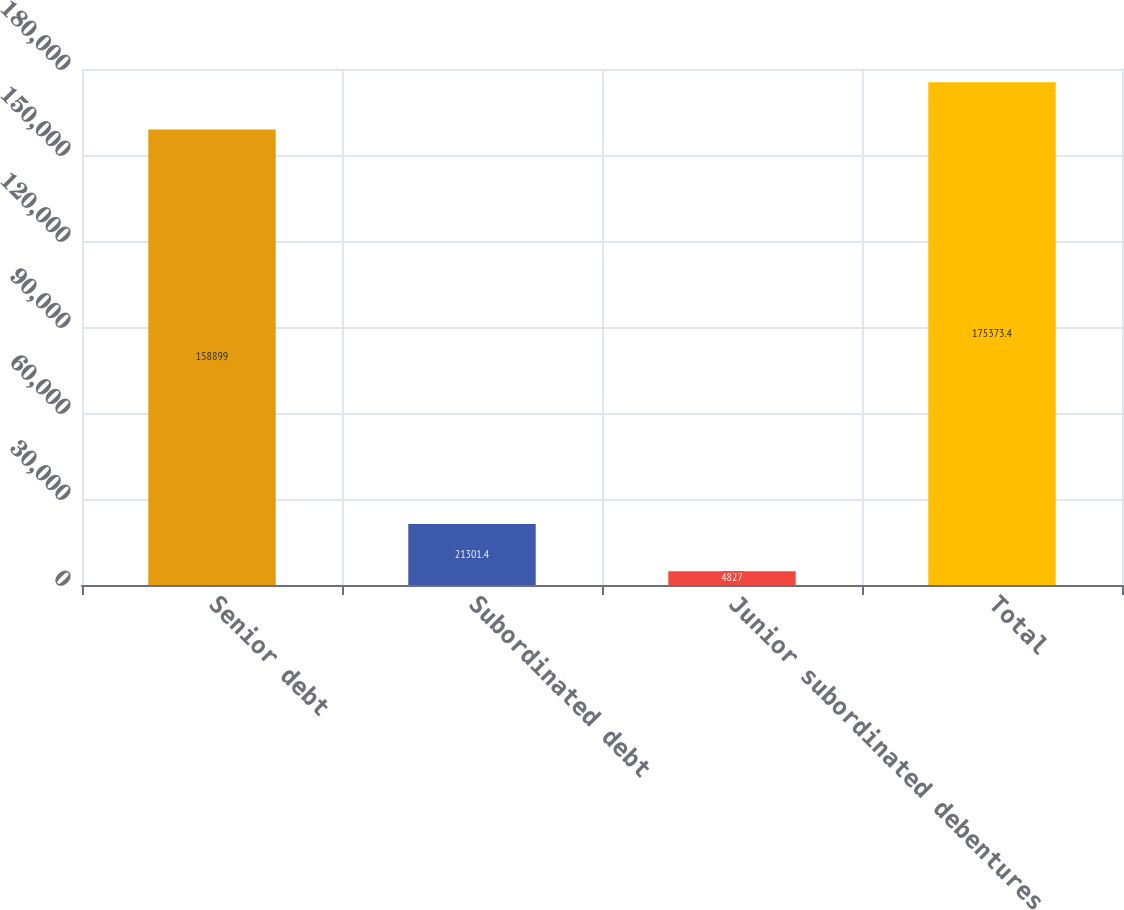Convert chart to OTSL. <chart><loc_0><loc_0><loc_500><loc_500><bar_chart><fcel>Senior debt<fcel>Subordinated debt<fcel>Junior subordinated debentures<fcel>Total<nl><fcel>158899<fcel>21301.4<fcel>4827<fcel>175373<nl></chart> 